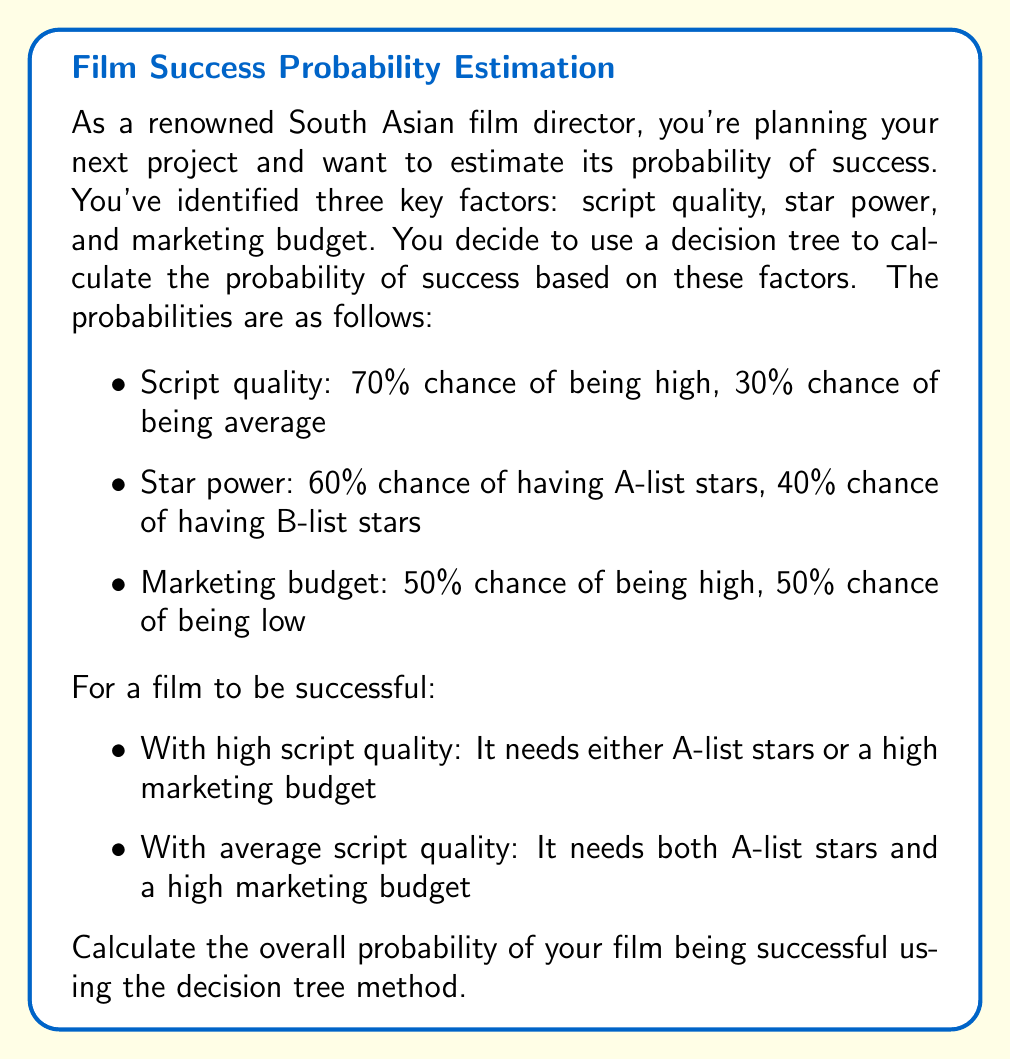What is the answer to this math problem? To solve this problem, we'll use a decision tree approach and the multiplication rule of probability. Let's break it down step by step:

1) First, let's consider the high script quality scenario (70% chance):

   a) With A-list stars (60% chance): Success
   b) With B-list stars (40% chance):
      - High marketing budget (50% chance): Success
      - Low marketing budget (50% chance): Failure

   Probability of success with high script quality:
   $$P(\text{success | high script}) = 0.70 \times (0.60 + 0.40 \times 0.50) = 0.70 \times 0.80 = 0.56$$

2) Now, let's consider the average script quality scenario (30% chance):

   Success requires both A-list stars (60% chance) and high marketing budget (50% chance)

   Probability of success with average script quality:
   $$P(\text{success | average script}) = 0.30 \times 0.60 \times 0.50 = 0.09$$

3) The total probability of success is the sum of these two probabilities:

   $$P(\text{success}) = P(\text{success | high script}) + P(\text{success | average script})$$
   $$P(\text{success}) = 0.56 + 0.09 = 0.65$$

Therefore, the overall probability of your film being successful is 0.65 or 65%.
Answer: The overall probability of the film being successful is 0.65 or 65%. 